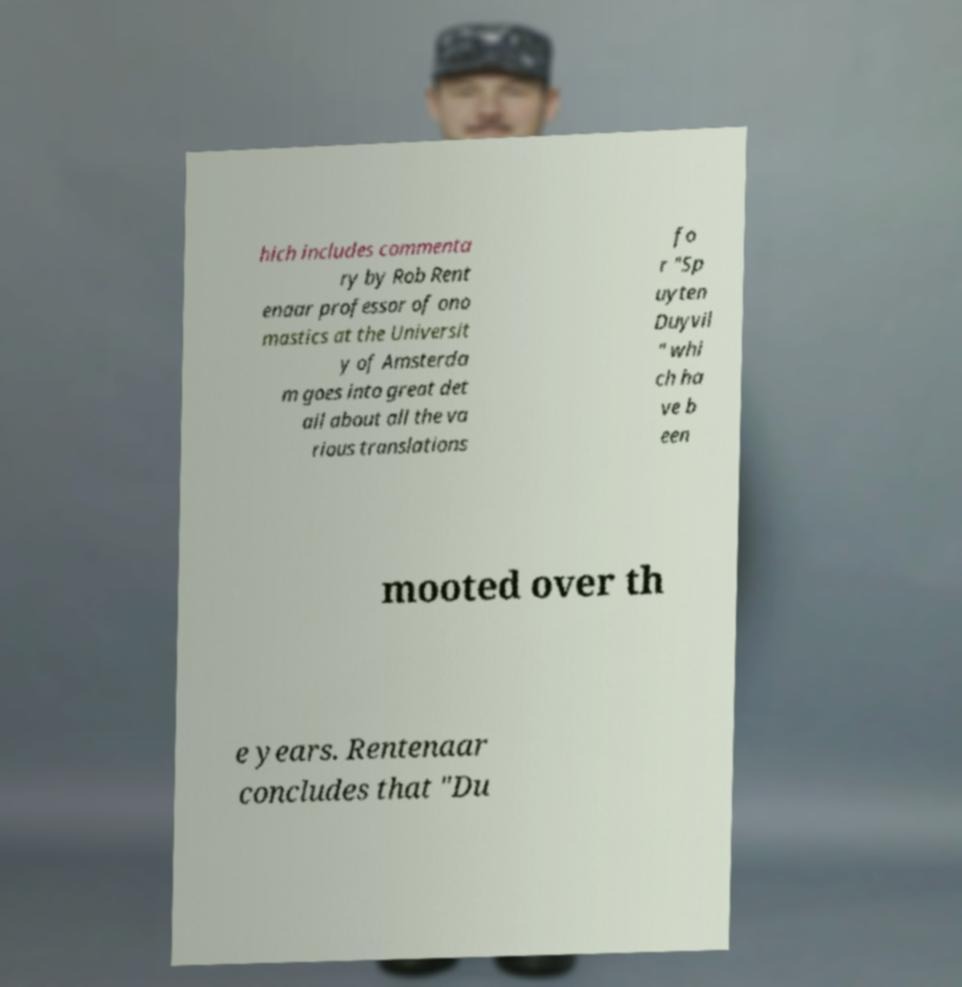For documentation purposes, I need the text within this image transcribed. Could you provide that? hich includes commenta ry by Rob Rent enaar professor of ono mastics at the Universit y of Amsterda m goes into great det ail about all the va rious translations fo r "Sp uyten Duyvil " whi ch ha ve b een mooted over th e years. Rentenaar concludes that "Du 